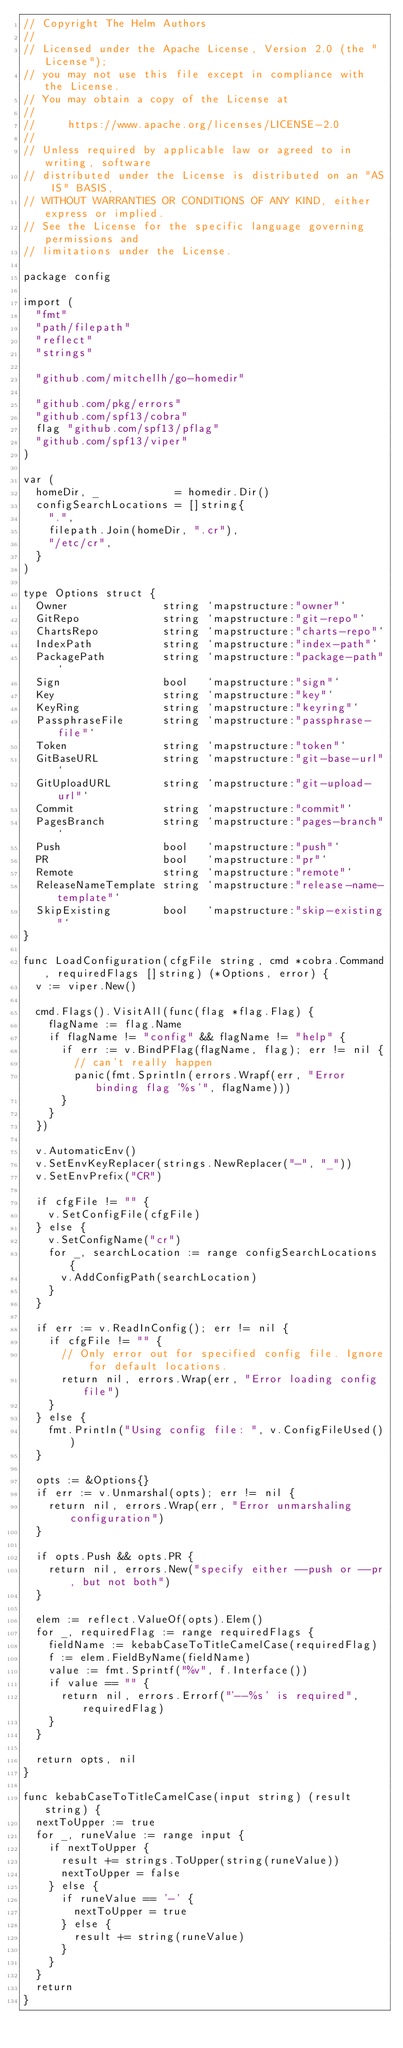<code> <loc_0><loc_0><loc_500><loc_500><_Go_>// Copyright The Helm Authors
//
// Licensed under the Apache License, Version 2.0 (the "License");
// you may not use this file except in compliance with the License.
// You may obtain a copy of the License at
//
//     https://www.apache.org/licenses/LICENSE-2.0
//
// Unless required by applicable law or agreed to in writing, software
// distributed under the License is distributed on an "AS IS" BASIS,
// WITHOUT WARRANTIES OR CONDITIONS OF ANY KIND, either express or implied.
// See the License for the specific language governing permissions and
// limitations under the License.

package config

import (
	"fmt"
	"path/filepath"
	"reflect"
	"strings"

	"github.com/mitchellh/go-homedir"

	"github.com/pkg/errors"
	"github.com/spf13/cobra"
	flag "github.com/spf13/pflag"
	"github.com/spf13/viper"
)

var (
	homeDir, _            = homedir.Dir()
	configSearchLocations = []string{
		".",
		filepath.Join(homeDir, ".cr"),
		"/etc/cr",
	}
)

type Options struct {
	Owner               string `mapstructure:"owner"`
	GitRepo             string `mapstructure:"git-repo"`
	ChartsRepo          string `mapstructure:"charts-repo"`
	IndexPath           string `mapstructure:"index-path"`
	PackagePath         string `mapstructure:"package-path"`
	Sign                bool   `mapstructure:"sign"`
	Key                 string `mapstructure:"key"`
	KeyRing             string `mapstructure:"keyring"`
	PassphraseFile      string `mapstructure:"passphrase-file"`
	Token               string `mapstructure:"token"`
	GitBaseURL          string `mapstructure:"git-base-url"`
	GitUploadURL        string `mapstructure:"git-upload-url"`
	Commit              string `mapstructure:"commit"`
	PagesBranch         string `mapstructure:"pages-branch"`
	Push                bool   `mapstructure:"push"`
	PR                  bool   `mapstructure:"pr"`
	Remote              string `mapstructure:"remote"`
	ReleaseNameTemplate string `mapstructure:"release-name-template"`
	SkipExisting        bool   `mapstructure:"skip-existing"`
}

func LoadConfiguration(cfgFile string, cmd *cobra.Command, requiredFlags []string) (*Options, error) {
	v := viper.New()

	cmd.Flags().VisitAll(func(flag *flag.Flag) {
		flagName := flag.Name
		if flagName != "config" && flagName != "help" {
			if err := v.BindPFlag(flagName, flag); err != nil {
				// can't really happen
				panic(fmt.Sprintln(errors.Wrapf(err, "Error binding flag '%s'", flagName)))
			}
		}
	})

	v.AutomaticEnv()
	v.SetEnvKeyReplacer(strings.NewReplacer("-", "_"))
	v.SetEnvPrefix("CR")

	if cfgFile != "" {
		v.SetConfigFile(cfgFile)
	} else {
		v.SetConfigName("cr")
		for _, searchLocation := range configSearchLocations {
			v.AddConfigPath(searchLocation)
		}
	}

	if err := v.ReadInConfig(); err != nil {
		if cfgFile != "" {
			// Only error out for specified config file. Ignore for default locations.
			return nil, errors.Wrap(err, "Error loading config file")
		}
	} else {
		fmt.Println("Using config file: ", v.ConfigFileUsed())
	}

	opts := &Options{}
	if err := v.Unmarshal(opts); err != nil {
		return nil, errors.Wrap(err, "Error unmarshaling configuration")
	}

	if opts.Push && opts.PR {
		return nil, errors.New("specify either --push or --pr, but not both")
	}

	elem := reflect.ValueOf(opts).Elem()
	for _, requiredFlag := range requiredFlags {
		fieldName := kebabCaseToTitleCamelCase(requiredFlag)
		f := elem.FieldByName(fieldName)
		value := fmt.Sprintf("%v", f.Interface())
		if value == "" {
			return nil, errors.Errorf("'--%s' is required", requiredFlag)
		}
	}

	return opts, nil
}

func kebabCaseToTitleCamelCase(input string) (result string) {
	nextToUpper := true
	for _, runeValue := range input {
		if nextToUpper {
			result += strings.ToUpper(string(runeValue))
			nextToUpper = false
		} else {
			if runeValue == '-' {
				nextToUpper = true
			} else {
				result += string(runeValue)
			}
		}
	}
	return
}
</code> 